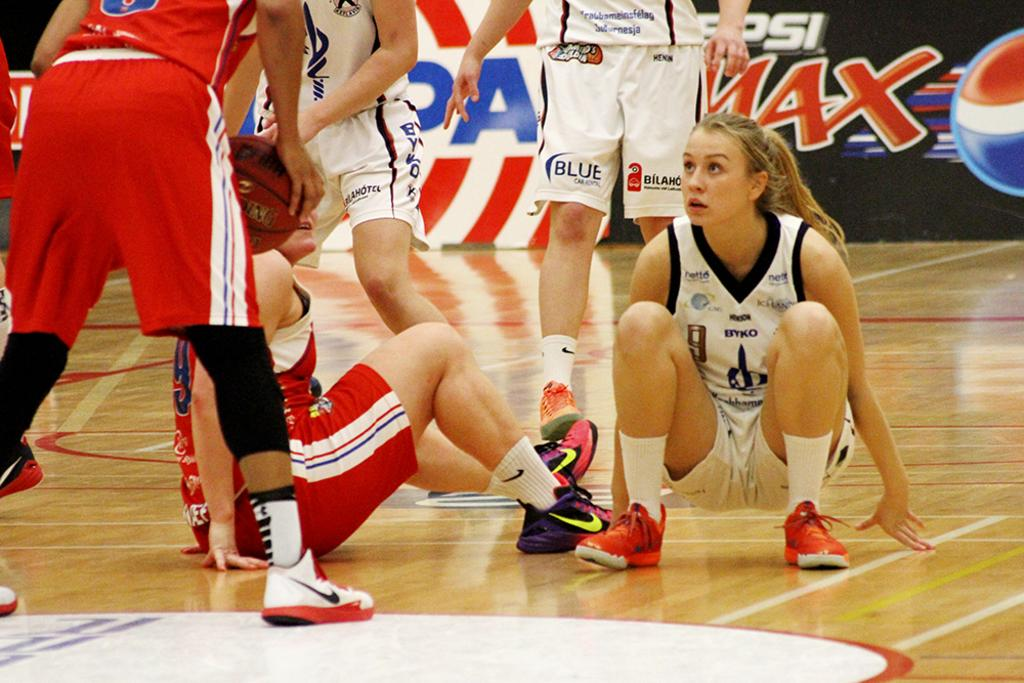Provide a one-sentence caption for the provided image. A girls basketball court with an ad for Pepsi Max in the background. 